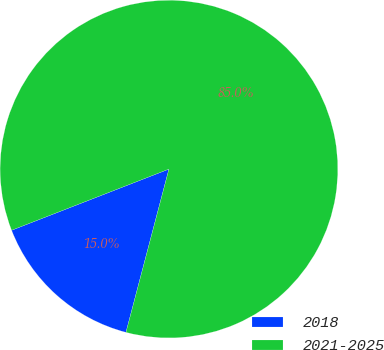Convert chart to OTSL. <chart><loc_0><loc_0><loc_500><loc_500><pie_chart><fcel>2018<fcel>2021-2025<nl><fcel>15.0%<fcel>85.0%<nl></chart> 